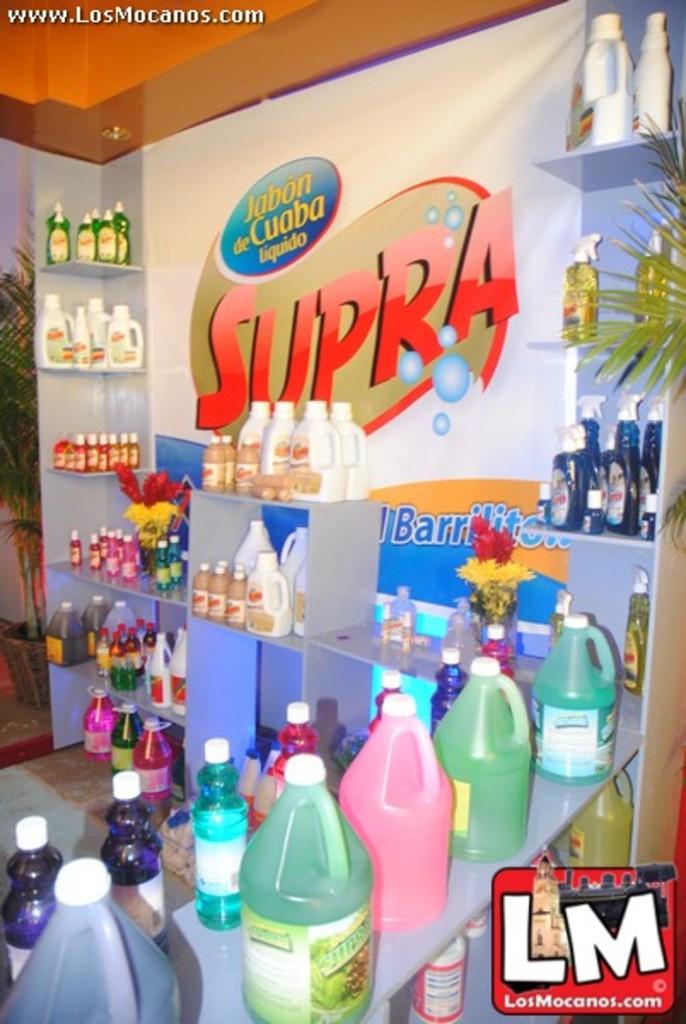What is the website shown in this image?
Offer a terse response. Losmocanos.com. What is the brand on the wall?
Make the answer very short. Supra. 